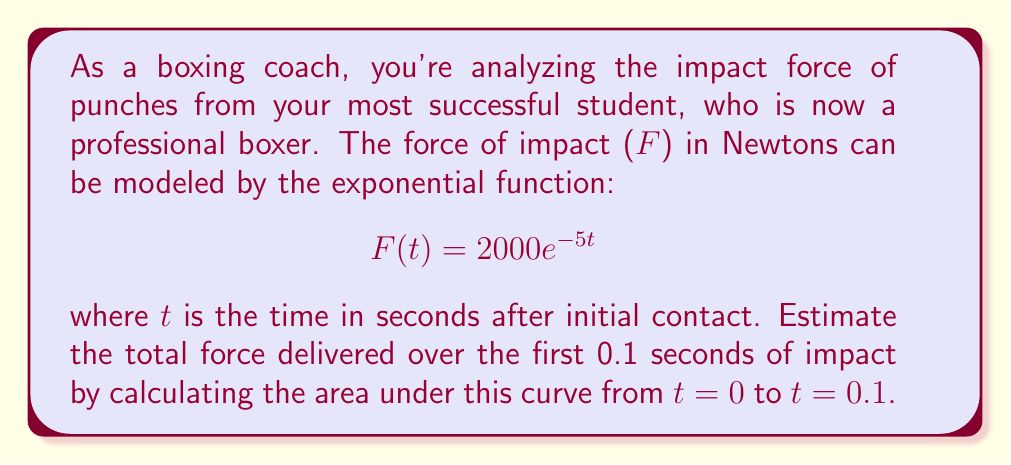Help me with this question. To estimate the total force delivered over the first 0.1 seconds, we need to calculate the definite integral of the force function from t = 0 to t = 0.1. This represents the area under the curve, which gives us the impulse (change in momentum) of the punch.

1) The integral we need to evaluate is:

   $$\int_0^{0.1} 2000e^{-5t} dt$$

2) To solve this, we can use the antiderivative of $e^{-5t}$:

   $$\int e^{-5t} dt = -\frac{1}{5}e^{-5t} + C$$

3) Applying the fundamental theorem of calculus:

   $$\left[-\frac{2000}{5}e^{-5t}\right]_0^{0.1}$$

4) Evaluating at the limits:

   $$-\frac{2000}{5}e^{-5(0.1)} - \left(-\frac{2000}{5}e^{-5(0)}\right)$$

5) Simplify:

   $$-400e^{-0.5} + 400$$

6) Calculate:

   $$-400(0.6065) + 400 = 357.4$$

Therefore, the estimated total force delivered over the first 0.1 seconds is approximately 357.4 N⋅s (Newton-seconds).
Answer: 357.4 N⋅s 